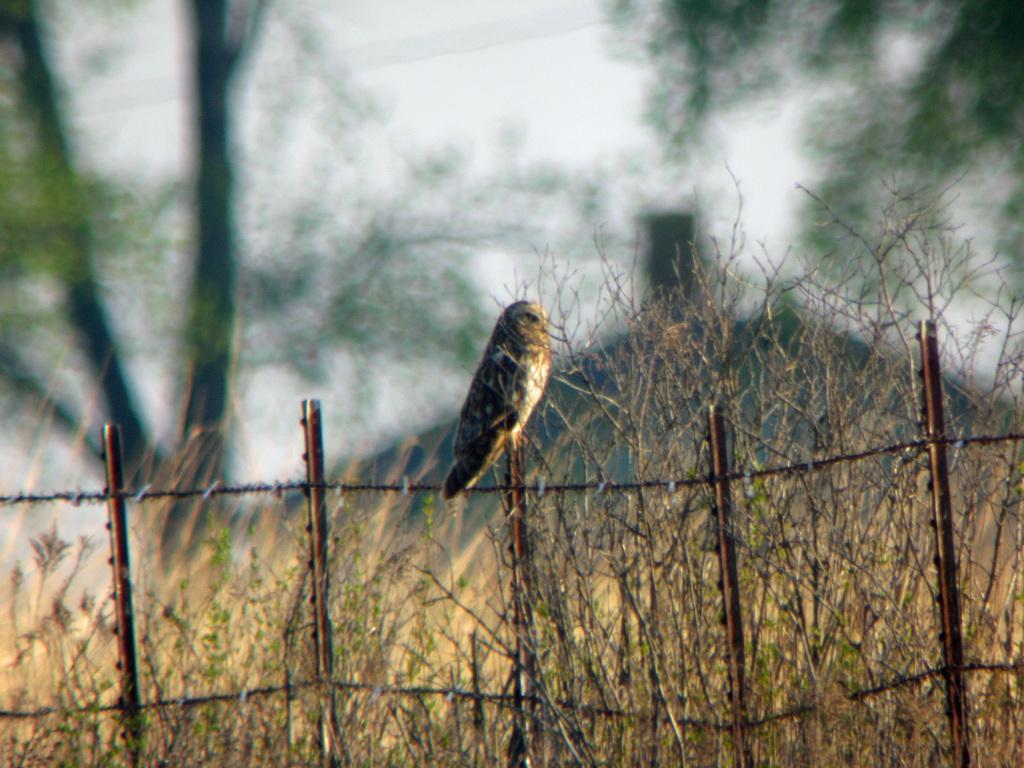Could you give a brief overview of what you see in this image? In the center of the image there is a fence and plants. On the fence, we can see one bird. In the background, we can see the trees and we can see it is blurred. 